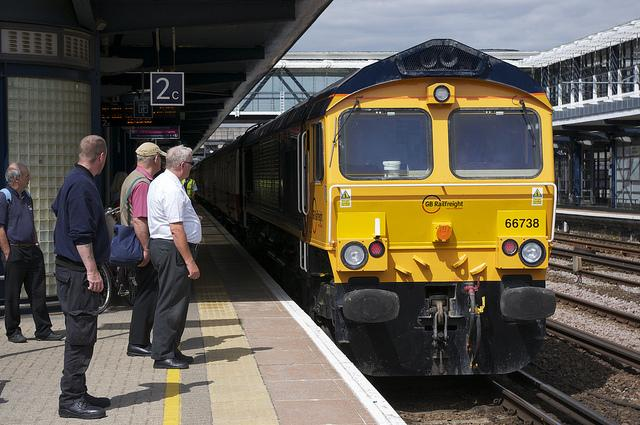Why is there a yellow line on the ground? safety 